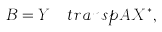Convert formula to latex. <formula><loc_0><loc_0><loc_500><loc_500>B = Y ^ { \dagger } \ t r a n s p { A } X ^ { * } ,</formula> 